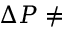<formula> <loc_0><loc_0><loc_500><loc_500>\Delta P \neq</formula> 